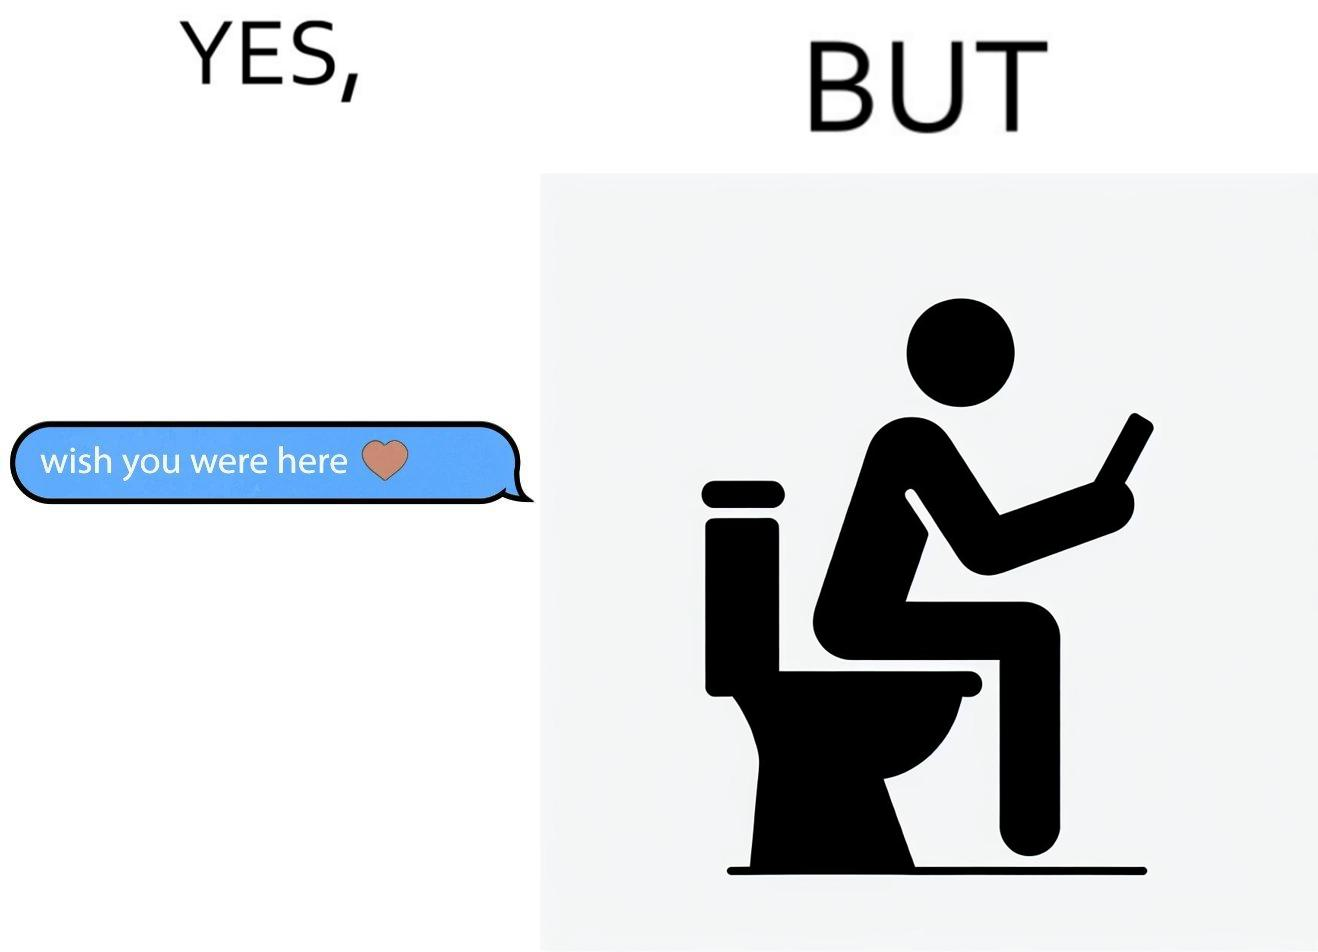Describe the content of this image. The images are funny since it shows how even though a man writes to his partner that he wishes she was there to show that he misses her, it would be inappropriate and gross if it were to happen literally as he is sitting on his toilet 